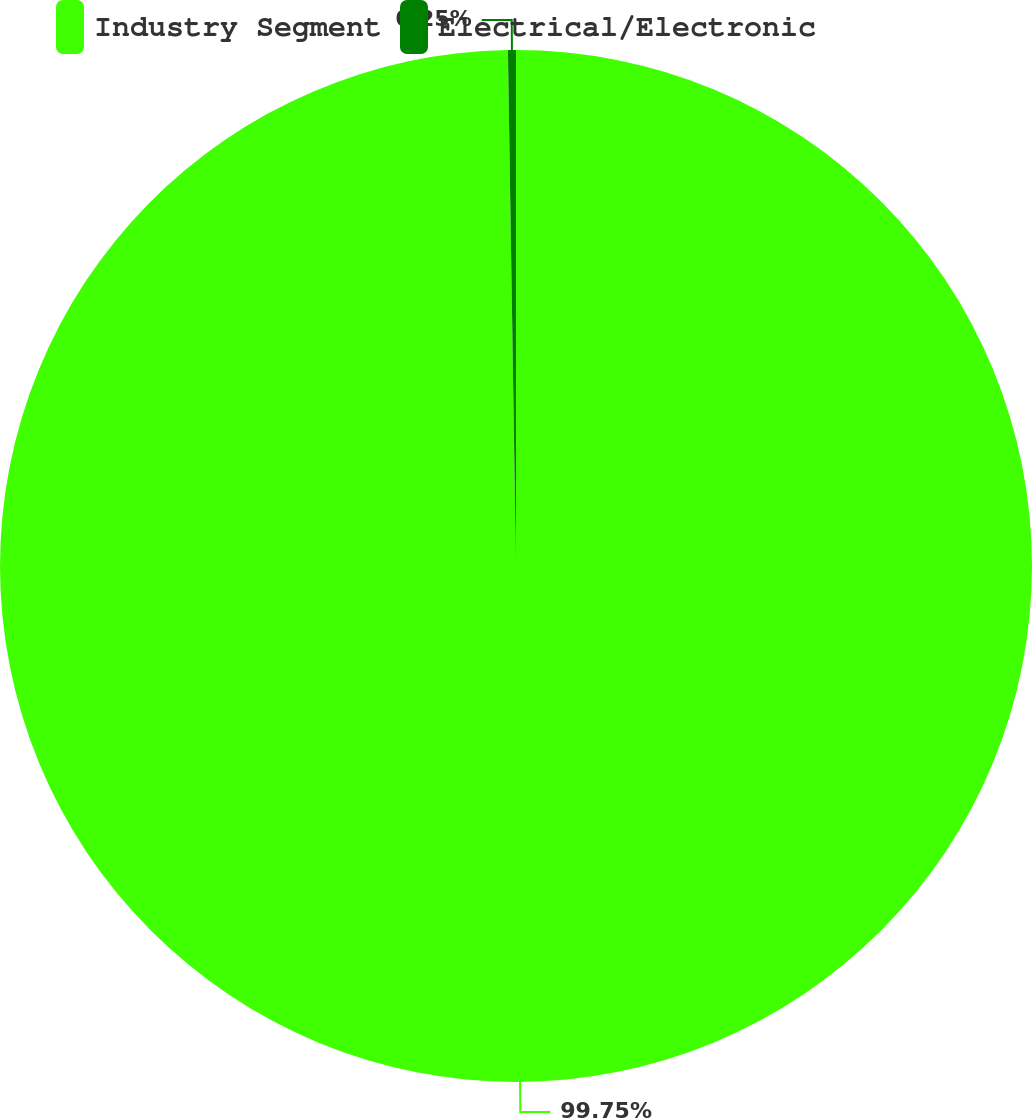Convert chart. <chart><loc_0><loc_0><loc_500><loc_500><pie_chart><fcel>Industry Segment<fcel>Electrical/Electronic<nl><fcel>99.75%<fcel>0.25%<nl></chart> 